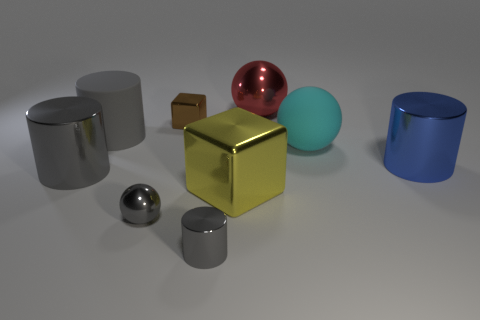There is a blue thing that is the same size as the cyan matte sphere; what shape is it?
Give a very brief answer. Cylinder. Do the gray rubber object and the tiny brown object have the same shape?
Your answer should be very brief. No. How many brown things have the same shape as the gray rubber object?
Give a very brief answer. 0. There is a gray metallic ball; how many gray things are on the right side of it?
Your response must be concise. 1. There is a large metal cylinder to the left of the large red thing; is it the same color as the tiny metallic ball?
Your answer should be compact. Yes. What number of metal cylinders have the same size as the blue object?
Offer a terse response. 1. There is a brown thing that is the same material as the big blue cylinder; what shape is it?
Give a very brief answer. Cube. Are there any tiny metal objects that have the same color as the tiny ball?
Offer a very short reply. Yes. What is the material of the cyan ball?
Your answer should be compact. Rubber. What number of objects are big objects or cylinders?
Your answer should be very brief. 7. 